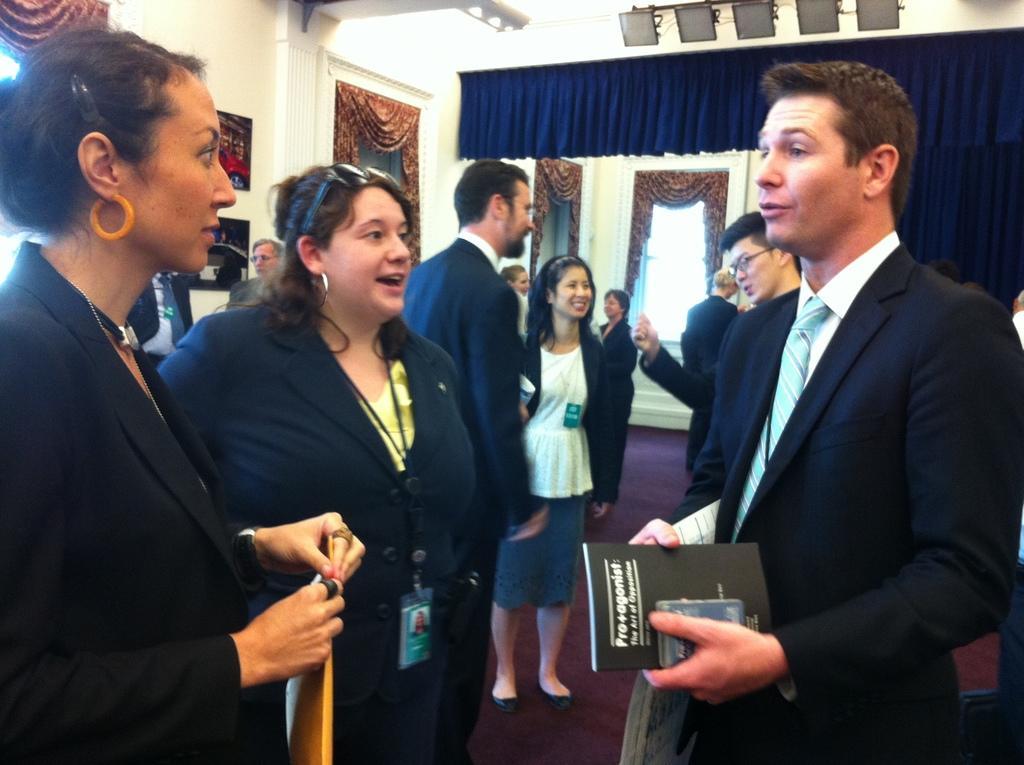Describe this image in one or two sentences. In this picture we can see a group of people on the ground, some people are holding files and in the background we can see a wall, photo frames, curtains and some objects. 